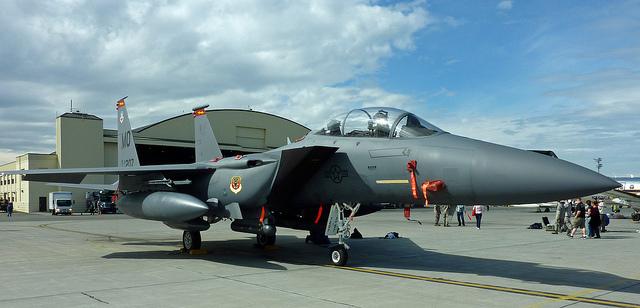Where is the truck that has the lights on?
Keep it brief. Background. What kind of plane is this?
Write a very short answer. Jet. Is this plane big?
Keep it brief. Yes. 